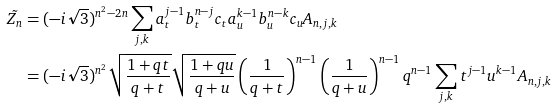<formula> <loc_0><loc_0><loc_500><loc_500>\tilde { Z _ { n } } & = ( - i \sqrt { 3 } ) ^ { n ^ { 2 } - 2 n } \sum _ { j , k } a _ { t } ^ { j - 1 } b _ { t } ^ { n - j } c _ { t } a _ { u } ^ { k - 1 } b _ { u } ^ { n - k } c _ { u } A _ { n , j , k } \\ & = ( - i \sqrt { 3 } ) ^ { n ^ { 2 } } \sqrt { \frac { 1 + q t } { q + t } } \sqrt { \frac { 1 + q u } { q + u } } \left ( \frac { 1 } { q + t } \right ) ^ { n - 1 } \left ( \frac { 1 } { q + u } \right ) ^ { n - 1 } q ^ { n - 1 } \sum _ { j , k } t ^ { j - 1 } u ^ { k - 1 } A _ { n , j , k }</formula> 